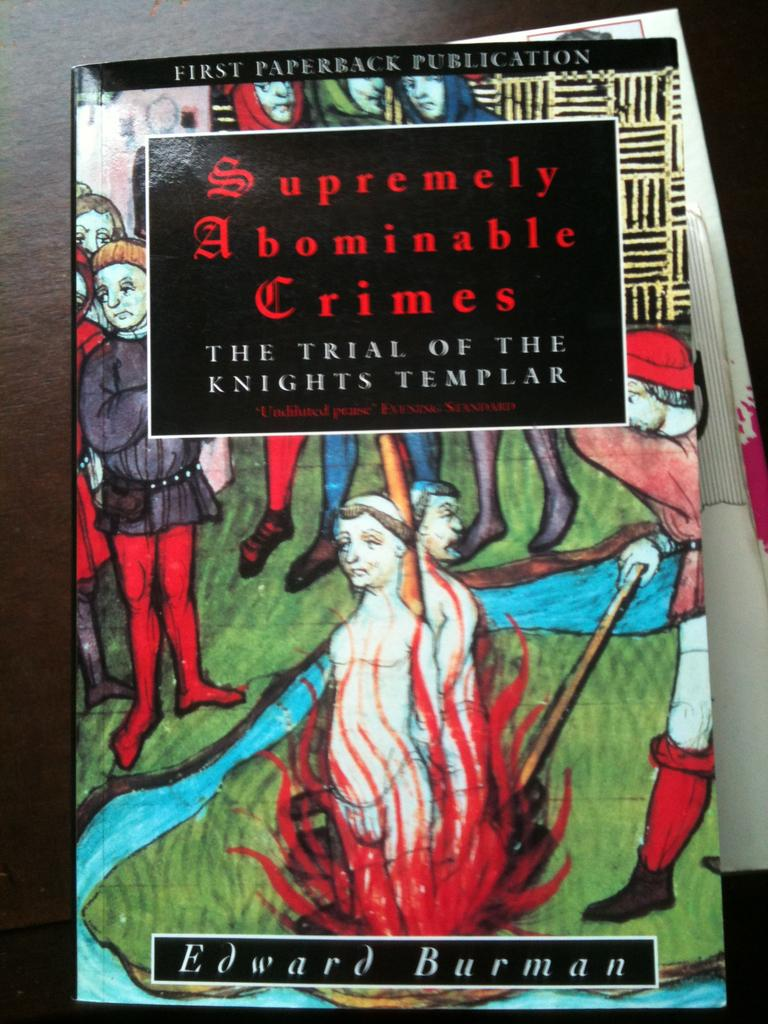What is present on the poster in the image? There is a poster in the image that contains an image of grass, water, and people. Can you describe the images on the poster? The poster contains images of grass, water, and people. What is the primary subject of the poster? The primary subject of the poster is a scene that includes grass, water, and people. Where is the shop located in the image? There is no shop present in the image; it only contains a poster with images of grass, water, and people. Can you see any twigs in the image? There are no twigs visible in the image; it only contains a poster with images of grass, water, and people. 